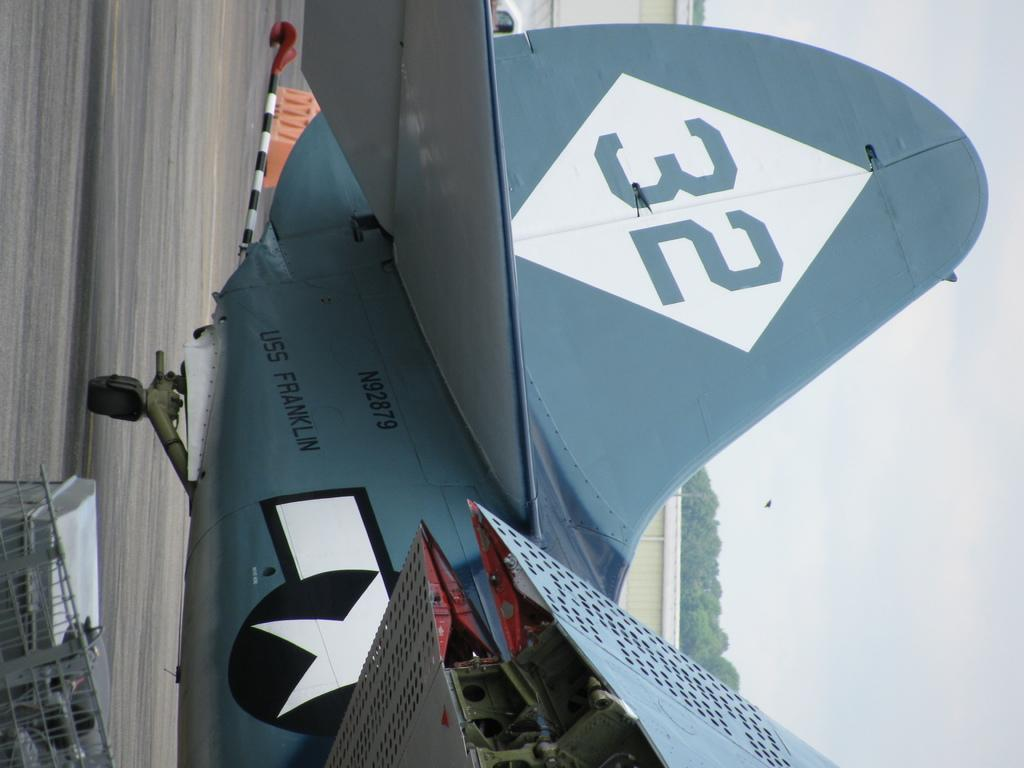<image>
Write a terse but informative summary of the picture. The blue aircraft has lettering that says USS Franklin and a large number 32 on the tail. 